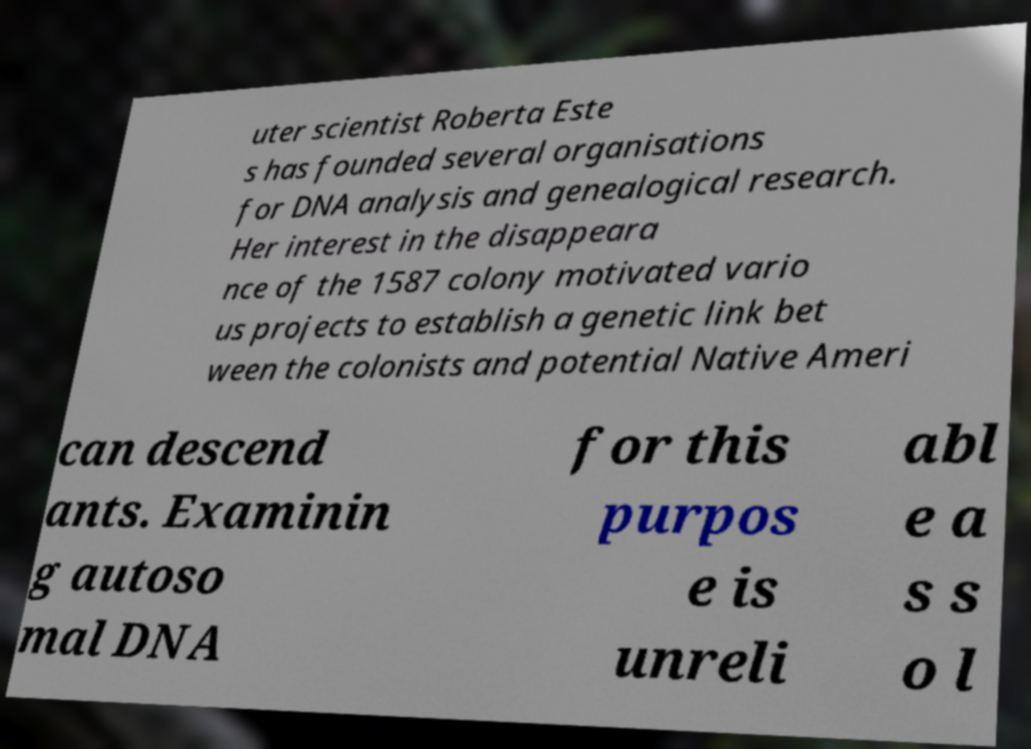Please identify and transcribe the text found in this image. uter scientist Roberta Este s has founded several organisations for DNA analysis and genealogical research. Her interest in the disappeara nce of the 1587 colony motivated vario us projects to establish a genetic link bet ween the colonists and potential Native Ameri can descend ants. Examinin g autoso mal DNA for this purpos e is unreli abl e a s s o l 